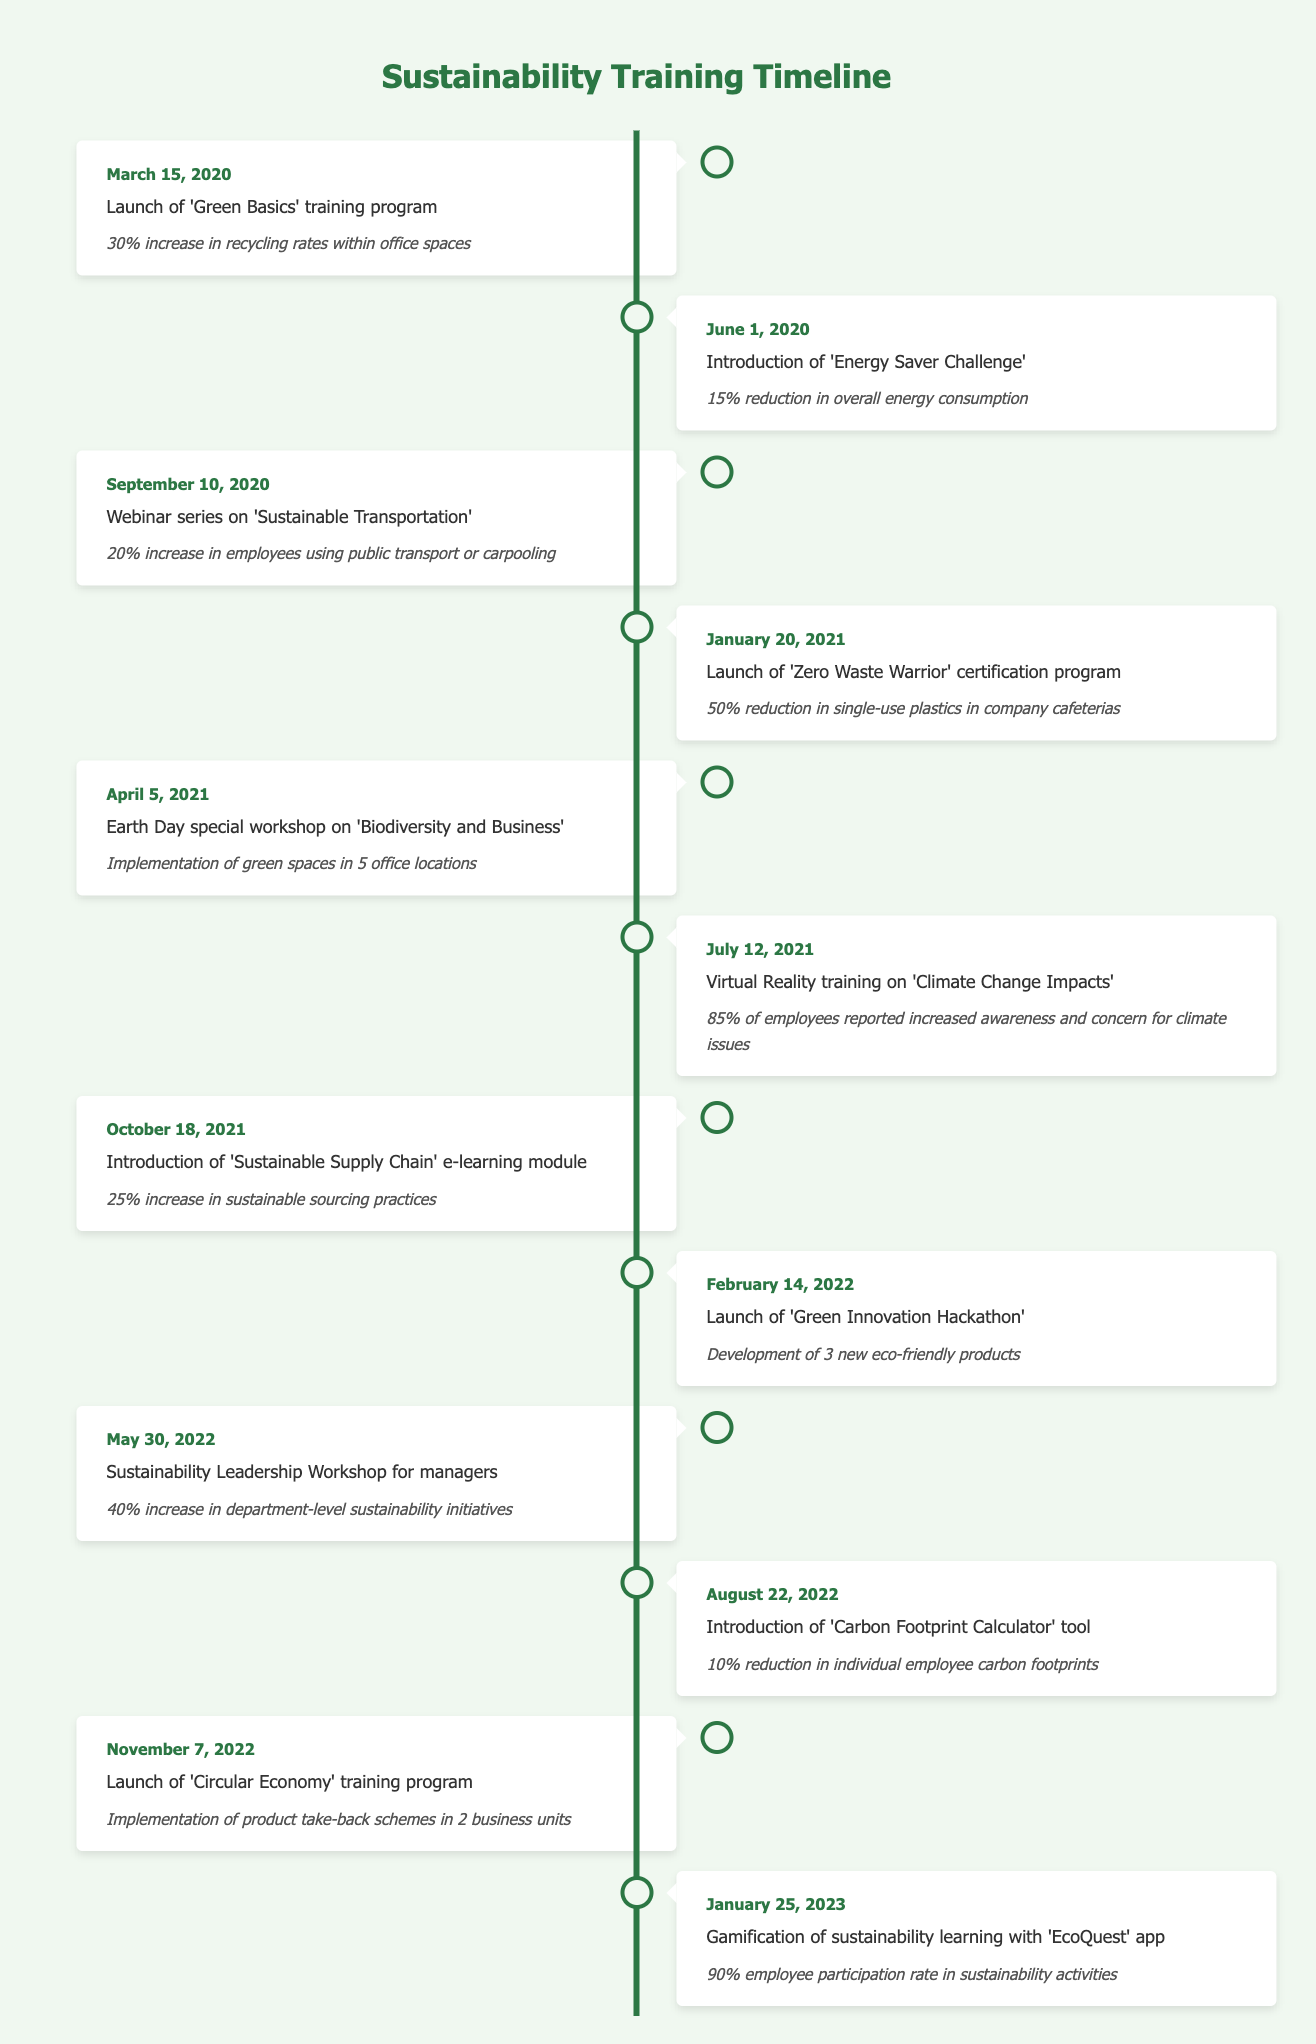What is the impact of the 'Green Basics' training program? The impact mentioned in the timeline for the 'Green Basics' training program is a 30% increase in recycling rates within office spaces.
Answer: 30% increase in recycling rates within office spaces When was the 'Circular Economy' training program launched? The launch date for the 'Circular Economy' training program is November 7, 2022, as per the timeline table.
Answer: November 7, 2022 What percentage reduction in single-use plastics was achieved after the 'Zero Waste Warrior' certification program? The table indicates that the 'Zero Waste Warrior' certification program led to a 50% reduction in single-use plastics in company cafeterias.
Answer: 50% reduction in single-use plastics How many new eco-friendly products were developed as a result of the 'Green Innovation Hackathon'? The timeline states that the 'Green Innovation Hackathon' resulted in the development of 3 new eco-friendly products.
Answer: 3 new eco-friendly products Was there a reduction in overall energy consumption after the 'Energy Saver Challenge'? Yes, the 'Energy Saver Challenge' resulted in a 15% reduction in overall energy consumption.
Answer: Yes How does the employee participation rate in sustainability activities compare before and after the introduction of the 'EcoQuest' app? Before the 'EcoQuest' app, there were various participation rates in sustainability activities; however, the timeline indicates that the participation rate reached 90% after the introduction of the app, suggesting a significant increase compared to previous rates.
Answer: Significant increase to 90% What was the overall outcome of the 'Sustainability Leadership Workshop for managers'? According to the table, the workshop led to a 40% increase in department-level sustainability initiatives, indicating its positive impact on leadership engagement in sustainability.
Answer: 40% increase in department-level sustainability initiatives Calculate the average percentage of increase in recycling rates and sustainable sourcing practices based on the timeline data. The recycling rate increase from the 'Green Basics' was 30% and the sustainable sourcing increase from the 'Sustainable Supply Chain' module was 25%. Summing them gives 55%. The average is 55% divided by 2 (the number of items) which equals 27.5%.
Answer: 27.5% Which training sessions had an impact on employee behavior related to transportation, and what was the specific impact? The 'Webinar series on Sustainable Transportation' trained employees to use public transport or carpooling, resulting in a 20% increase in the number of employees utilizing these modes of transport.
Answer: 20% increase in public transport or carpooling usage 